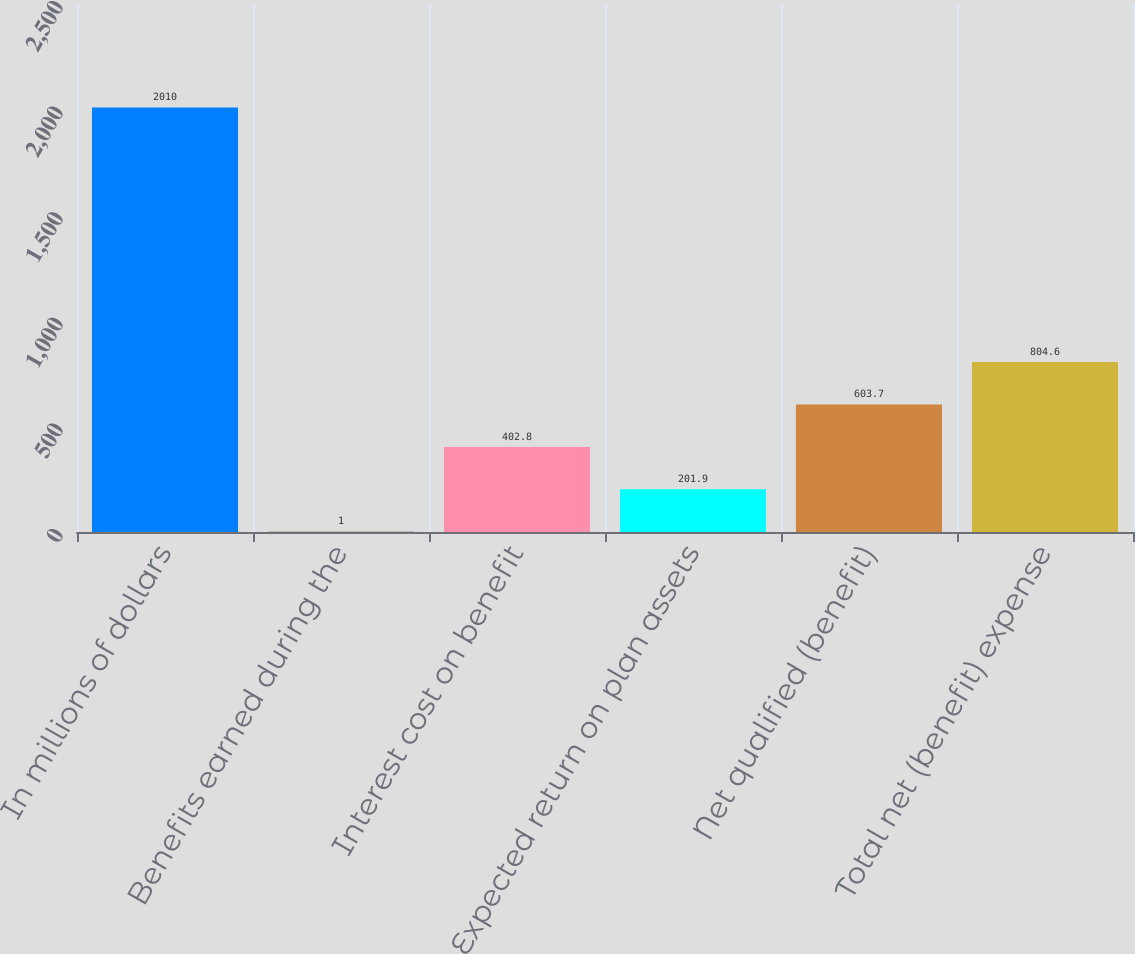Convert chart to OTSL. <chart><loc_0><loc_0><loc_500><loc_500><bar_chart><fcel>In millions of dollars<fcel>Benefits earned during the<fcel>Interest cost on benefit<fcel>Expected return on plan assets<fcel>Net qualified (benefit)<fcel>Total net (benefit) expense<nl><fcel>2010<fcel>1<fcel>402.8<fcel>201.9<fcel>603.7<fcel>804.6<nl></chart> 